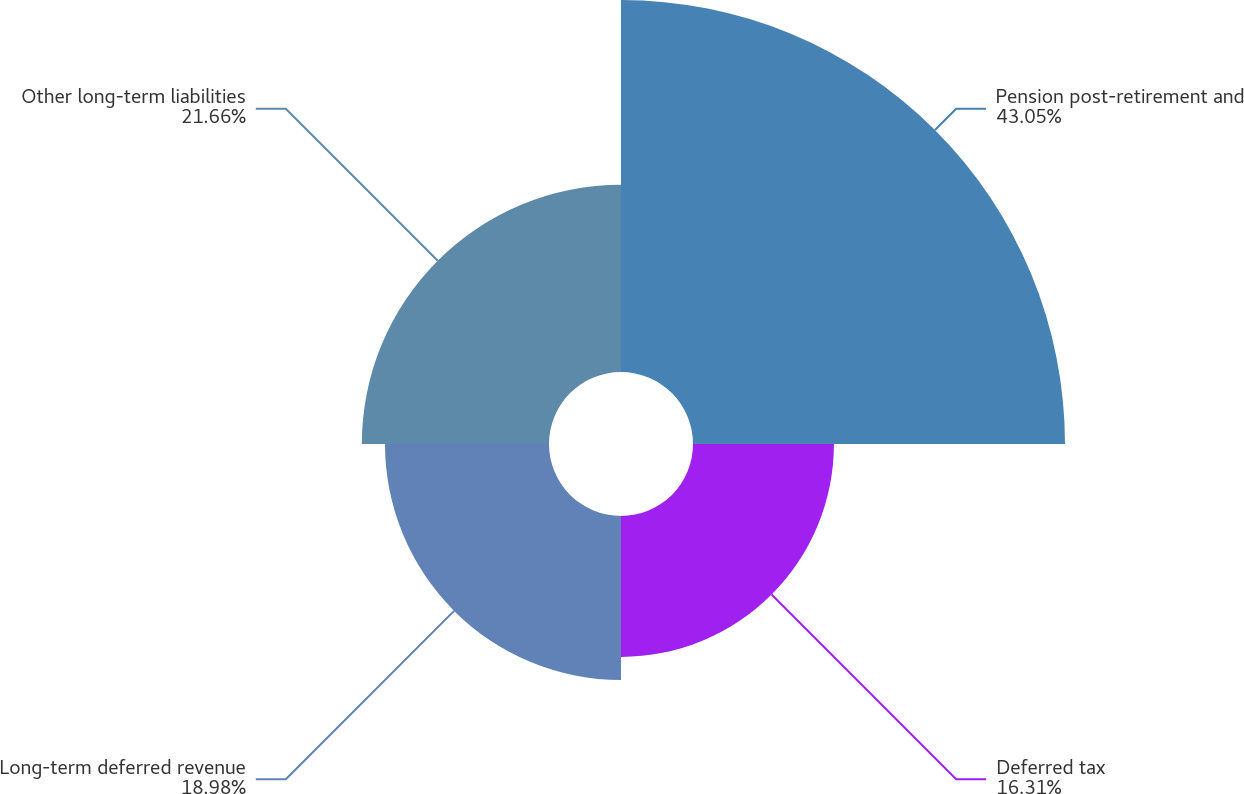Convert chart to OTSL. <chart><loc_0><loc_0><loc_500><loc_500><pie_chart><fcel>Pension post-retirement and<fcel>Deferred tax<fcel>Long-term deferred revenue<fcel>Other long-term liabilities<nl><fcel>43.05%<fcel>16.31%<fcel>18.98%<fcel>21.66%<nl></chart> 